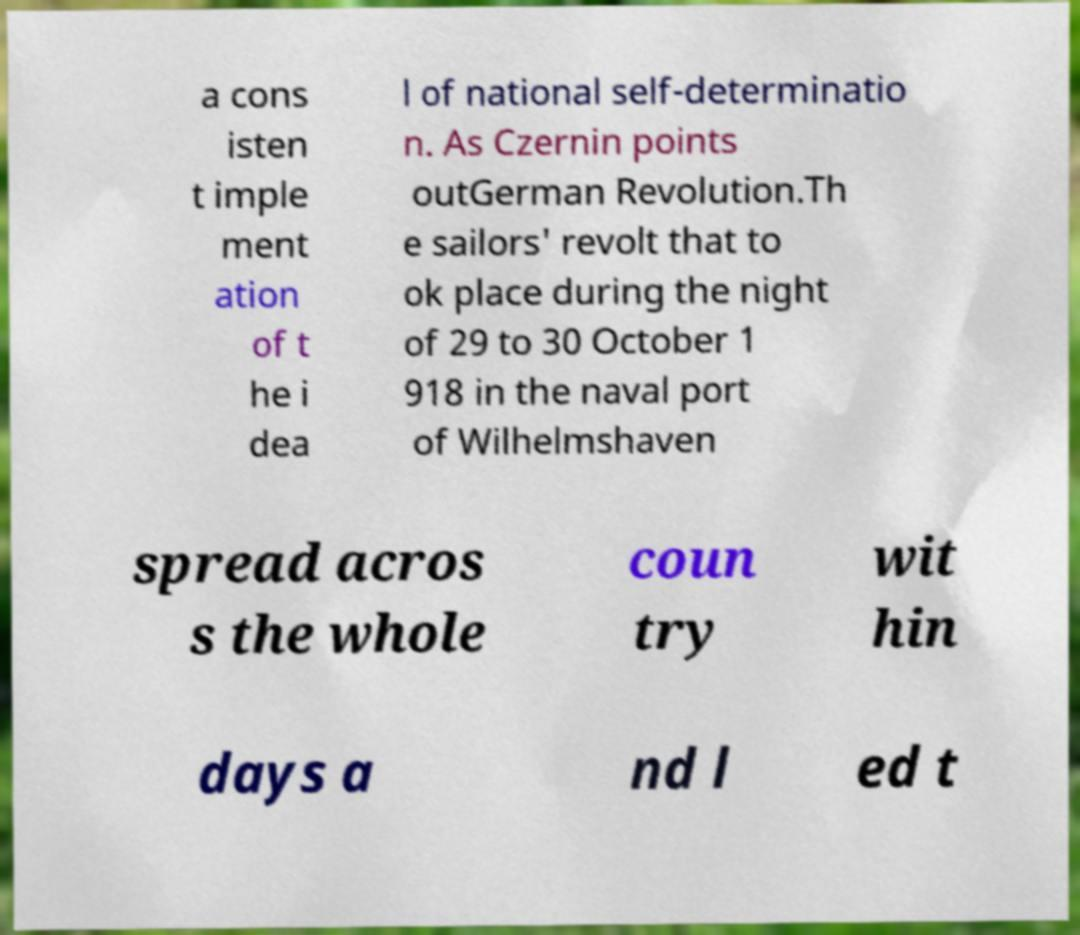Please identify and transcribe the text found in this image. a cons isten t imple ment ation of t he i dea l of national self-determinatio n. As Czernin points outGerman Revolution.Th e sailors' revolt that to ok place during the night of 29 to 30 October 1 918 in the naval port of Wilhelmshaven spread acros s the whole coun try wit hin days a nd l ed t 